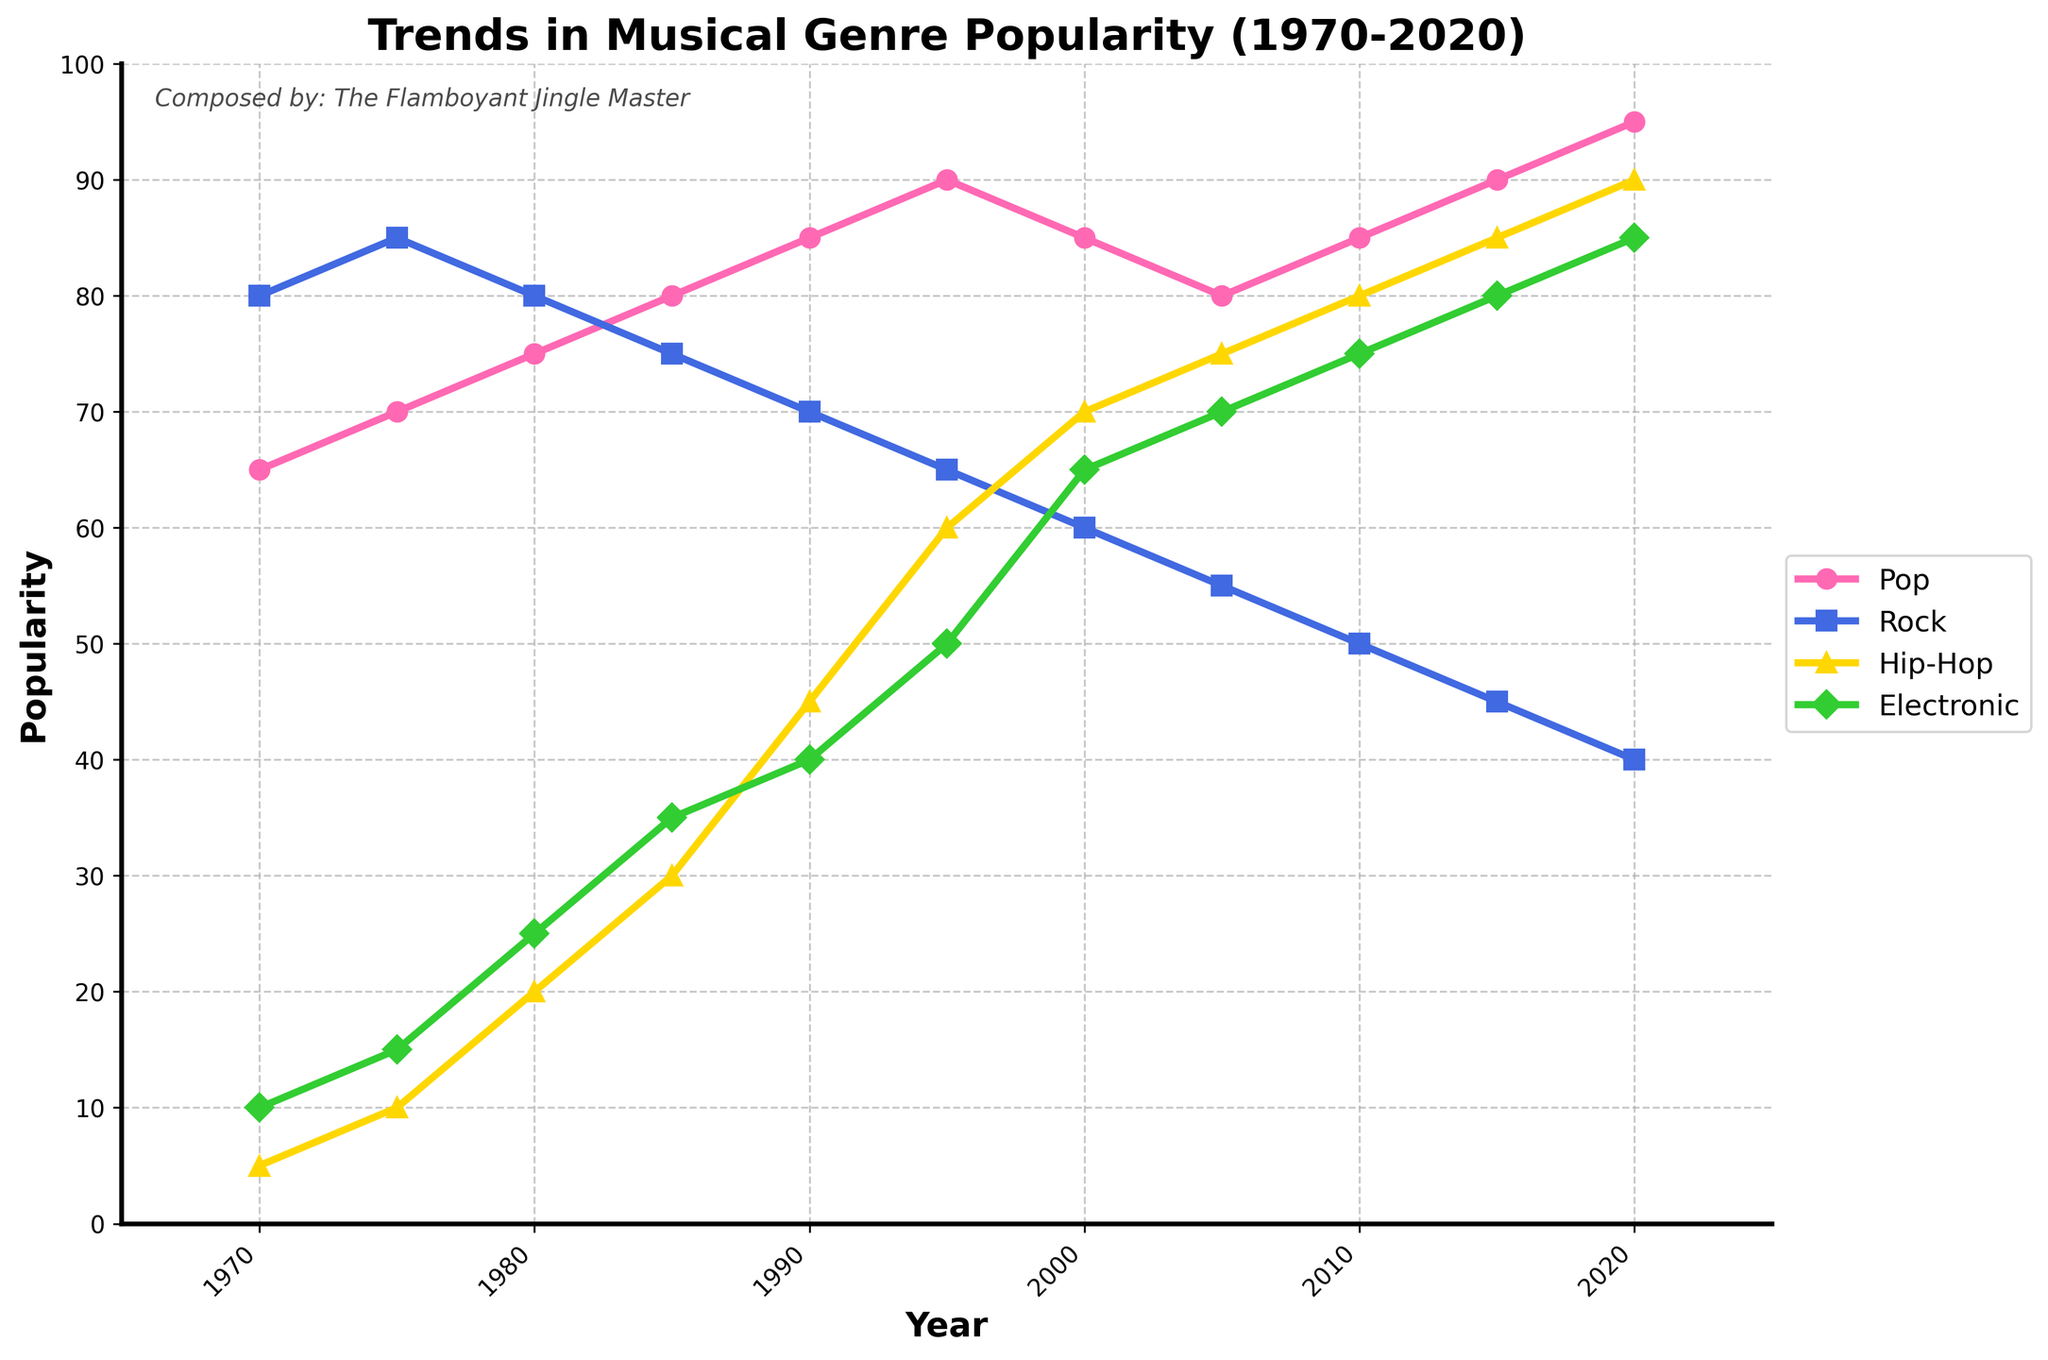Which genre had the highest popularity in 1990? To find this, look at the values for all genres in the year 1990. Compare the values for Pop, Rock, Hip-Hop, and Electronic. The genre with the highest value is the answer.
Answer: Pop Which genre showed the steepest increase in popularity between 1970 and 2020? To identify the steepest increase, examine the rise in popularity for each genre over the period from 1970 to 2020. Calculating the difference for each genre: Pop (95-65=30), Rock (40-80=-40), Hip-Hop (90-5=85), Electronic (85-10=75). Hip-Hop had the steepest increase.
Answer: Hip-Hop What is the average popularity of Rock music between 1970 and 2000? Calculate the average by summing up the popularity for Rock from 1970 to 2000 and then dividing by the number of data points. Sum of Rock (80+85+80+75+70+65+60) = 515; number of data points = 7. So, the average is 515/7 = 73.57.
Answer: 73.57 When did Electronic music first surpass a popularity of 50? Look for the first instance in the Electronic genre where the value is greater than 50. This happens in 1995.
Answer: 1995 How did the popularity of Pop change from 2010 to 2020? Compare the popularity values for Pop in 2010 and 2020. The values are 85 in 2010 and 95 in 2020. The change is 95-85 = 10.
Answer: Increased by 10 In which year were Pop and Rock equally popular? Look for the year where the values for Pop and Rock are equal. This occurs in 1985 when both have a value of 75.
Answer: 1985 Which genre had the lowest popularity in 2005 and what was its value? Check the values for all genres in 2005. The lowest value is for Rock with a popularity of 55.
Answer: Rock, 55 Was there any year where the popularity of Hip-Hop was at its peak? Identify the maximum value for Hip-Hop and find which year it corresponds to. The max value for Hip-Hop is 90, occurring in 2020.
Answer: 2020 What is the combined popularity of Rock and Electronic music in 1985? Sum the values of Rock and Electronic in the year 1985. Rock = 75, Electronic = 35. Combined popularity = 75 + 35 = 110.
Answer: 110 Compare the popularity of Pop and Electronic music in 2020. Which is higher and by how much? Look at the values for Pop and Electronic in 2020. Pop = 95, Electronic = 85. The difference is 95 - 85 = 10. Pop is higher by 10.
Answer: Pop, 10 